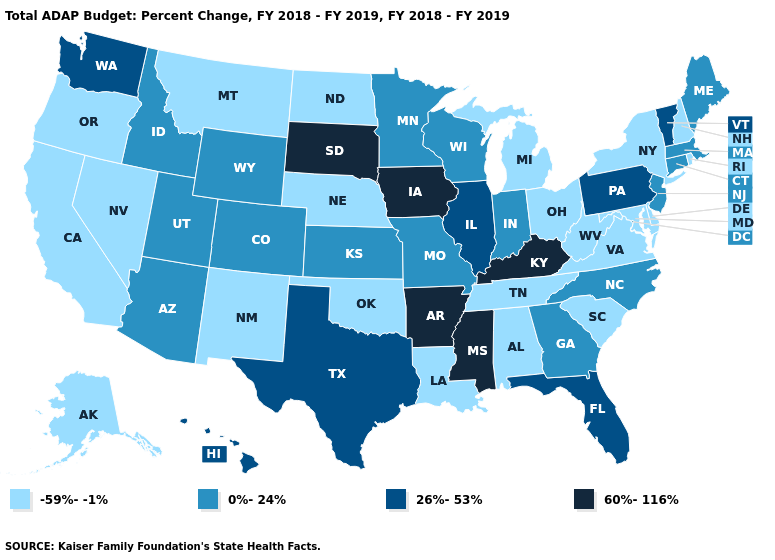Does Georgia have the same value as Colorado?
Answer briefly. Yes. Does Connecticut have the lowest value in the USA?
Answer briefly. No. What is the highest value in the Northeast ?
Answer briefly. 26%-53%. Among the states that border Massachusetts , does Connecticut have the lowest value?
Quick response, please. No. Name the states that have a value in the range 0%-24%?
Short answer required. Arizona, Colorado, Connecticut, Georgia, Idaho, Indiana, Kansas, Maine, Massachusetts, Minnesota, Missouri, New Jersey, North Carolina, Utah, Wisconsin, Wyoming. Does the map have missing data?
Write a very short answer. No. Is the legend a continuous bar?
Be succinct. No. What is the value of California?
Answer briefly. -59%--1%. What is the highest value in the South ?
Write a very short answer. 60%-116%. Name the states that have a value in the range 0%-24%?
Give a very brief answer. Arizona, Colorado, Connecticut, Georgia, Idaho, Indiana, Kansas, Maine, Massachusetts, Minnesota, Missouri, New Jersey, North Carolina, Utah, Wisconsin, Wyoming. Which states have the highest value in the USA?
Quick response, please. Arkansas, Iowa, Kentucky, Mississippi, South Dakota. Among the states that border Maine , which have the lowest value?
Answer briefly. New Hampshire. Is the legend a continuous bar?
Quick response, please. No. What is the lowest value in states that border Minnesota?
Be succinct. -59%--1%. Does the map have missing data?
Quick response, please. No. 